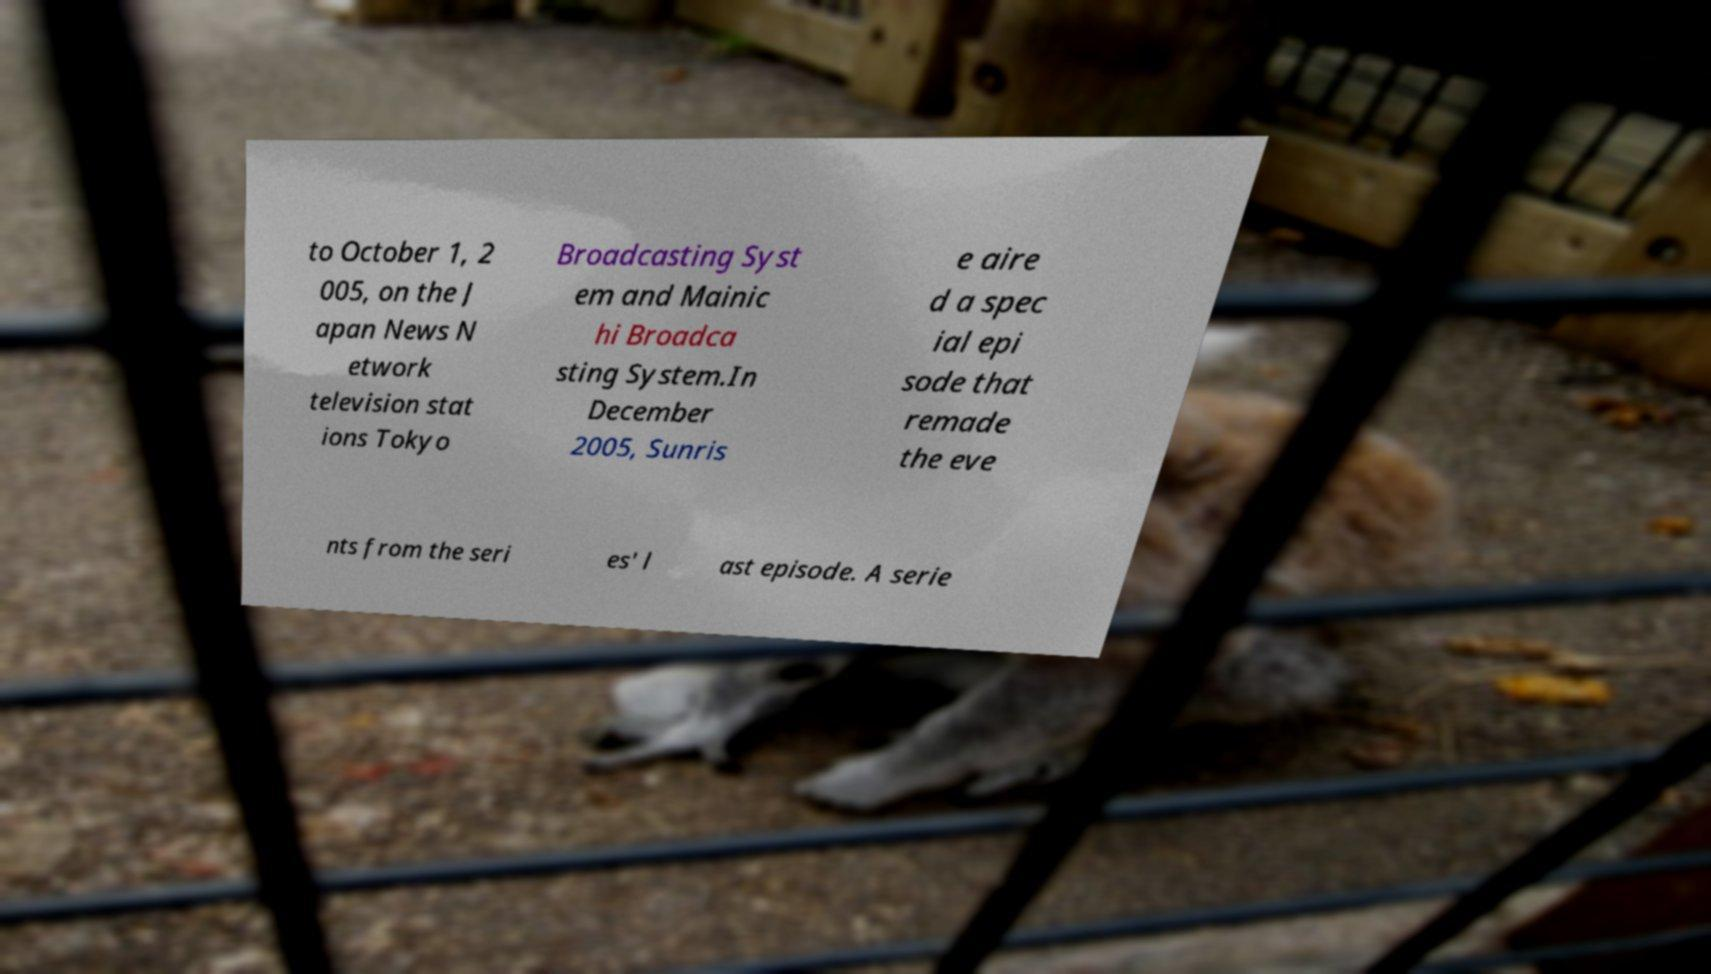For documentation purposes, I need the text within this image transcribed. Could you provide that? to October 1, 2 005, on the J apan News N etwork television stat ions Tokyo Broadcasting Syst em and Mainic hi Broadca sting System.In December 2005, Sunris e aire d a spec ial epi sode that remade the eve nts from the seri es' l ast episode. A serie 